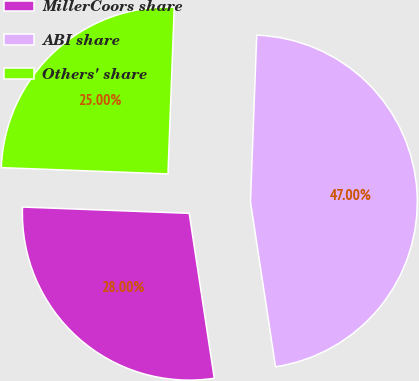<chart> <loc_0><loc_0><loc_500><loc_500><pie_chart><fcel>MillerCoors share<fcel>ABI share<fcel>Others' share<nl><fcel>28.0%<fcel>47.0%<fcel>25.0%<nl></chart> 